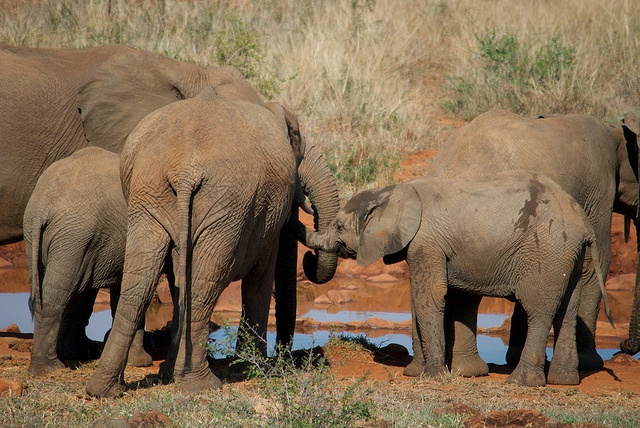Describe the objects in this image and their specific colors. I can see elephant in gray, tan, and black tones, elephant in gray, tan, and maroon tones, elephant in gray, maroon, and tan tones, elephant in gray and tan tones, and elephant in gray, black, and tan tones in this image. 